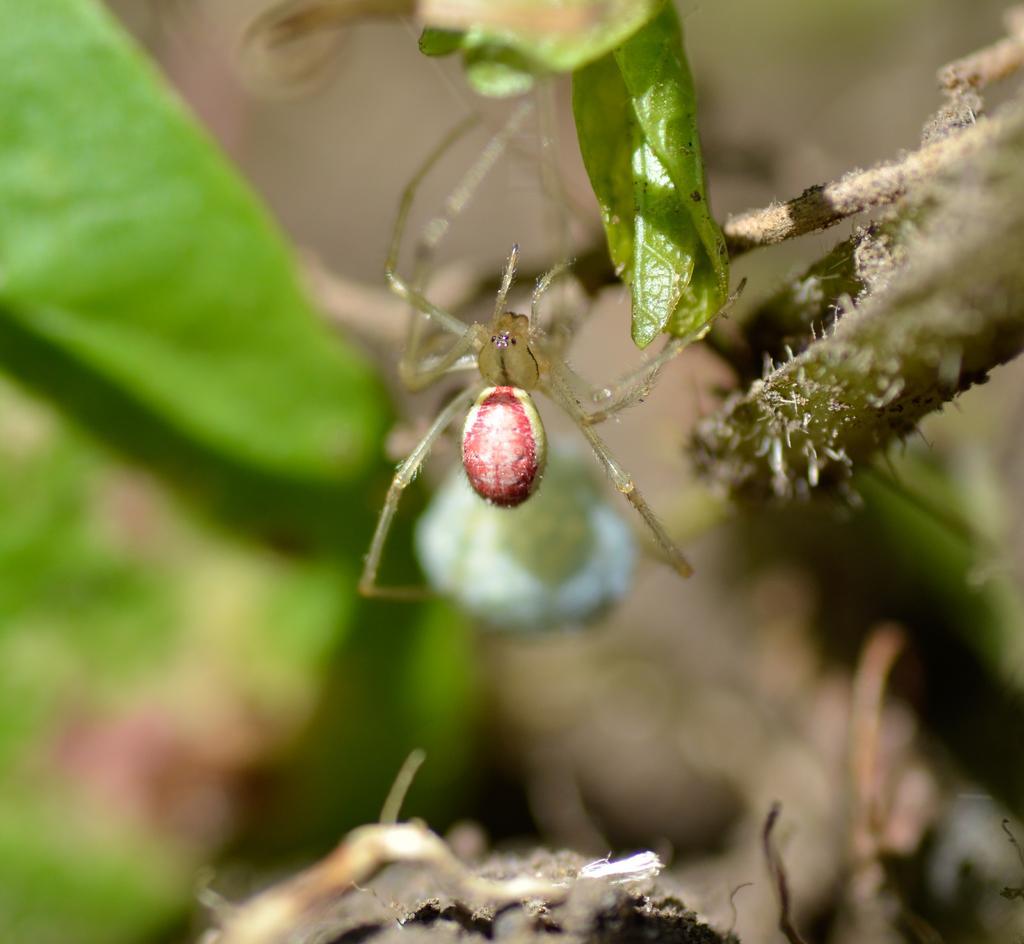Could you give a brief overview of what you see in this image? In this image, we can see an insect on the green leaf and there is a blur background. 